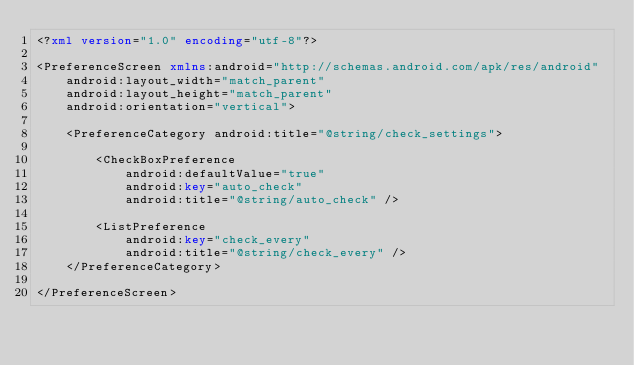<code> <loc_0><loc_0><loc_500><loc_500><_XML_><?xml version="1.0" encoding="utf-8"?>

<PreferenceScreen xmlns:android="http://schemas.android.com/apk/res/android"
    android:layout_width="match_parent"
    android:layout_height="match_parent"
    android:orientation="vertical">

    <PreferenceCategory android:title="@string/check_settings">

        <CheckBoxPreference
            android:defaultValue="true"
            android:key="auto_check"
            android:title="@string/auto_check" />

        <ListPreference
            android:key="check_every"
            android:title="@string/check_every" />
    </PreferenceCategory>

</PreferenceScreen></code> 